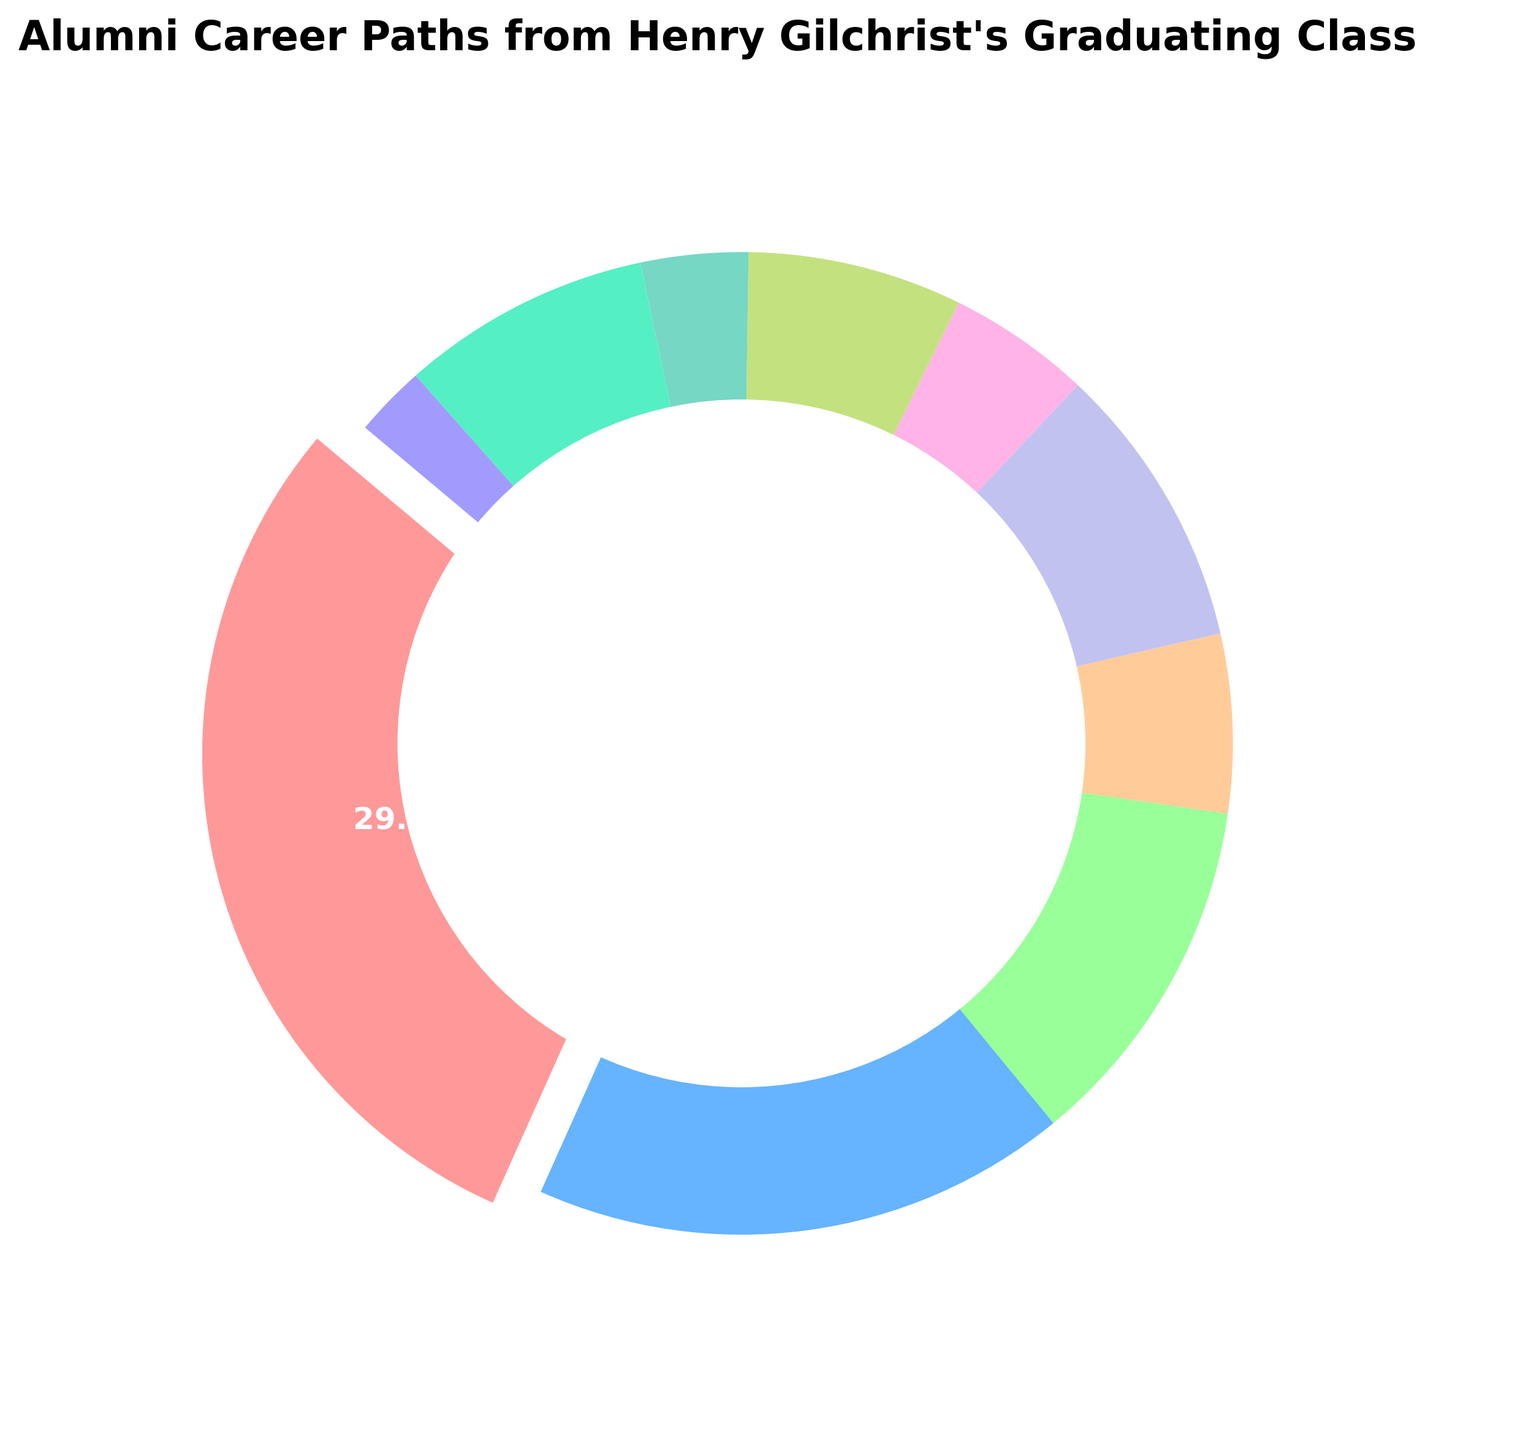What is the largest career path among Henry Gilchrist's alumni? The largest section in the pie chart is highlighted with an exploded segment, and it is labeled "Law," with 25 participants.
Answer: Law What percentage of alumni pursued careers in Healthcare? The Healthcare segment is labeled as "5.6%" in the chart.
Answer: 5.6% What is the combined percentage of alumni in Government and Non-Profit sectors? Government is labeled as "6.7%" and Non-Profit is labeled as "3.3%". Adding these percentages: 6.7 + 3.3 = 10%.
Answer: 10% Which careers have fewer participants than Technology? Technology has 7 participants. Arts with 4, Government with 6, Non-Profit with 3, and Other with 2 participants all have fewer participants than Technology.
Answer: Arts, Government, Non-Profit, Other How many more alumni chose careers in Law compared to Business? Law has 25 participants and Business has 15 participants. 25 - 15 = 10.
Answer: 10 What are the colors representing Technology and Academia on the chart? By looking at the pie chart, the color for Technology is a light green, and Academia is a medium green.
Answer: Light Green (Technology), Medium Green (Academia) What is the sum of alumni in Engineering, Healthcare, and Arts sectors? Engineering has 8, Healthcare has 5, and Arts has 4 participants. Adding these together: 8 + 5 + 4 = 17.
Answer: 17 Compare the proportions of alumni in Law and Technology. How many times more alumni pursued Law compared to Technology? Law has 25 participants and Technology has 7 participants. The ratio is 25/7 ≈ 3.57 times.
Answer: Approximately 3.6 times What percentage of alumni pursued careers in Engineering and Technology combined? Engineering is labeled as "8.9%" and Technology as "7.8%". Adding these percentages: 8.9 + 7.8 = 16.7%.
Answer: 16.7% 